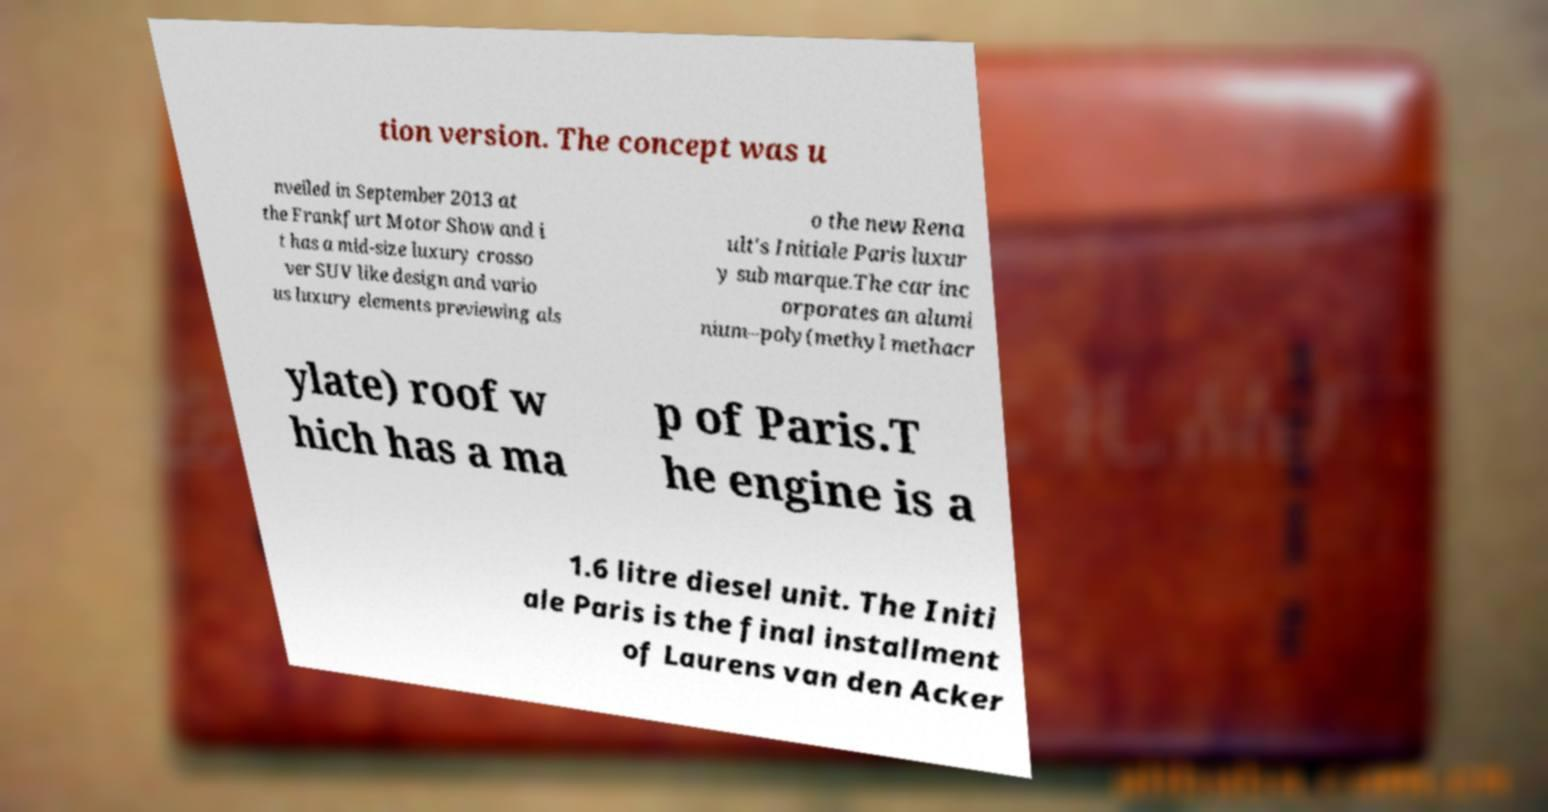I need the written content from this picture converted into text. Can you do that? tion version. The concept was u nveiled in September 2013 at the Frankfurt Motor Show and i t has a mid-size luxury crosso ver SUV like design and vario us luxury elements previewing als o the new Rena ult's Initiale Paris luxur y sub marque.The car inc orporates an alumi nium–poly(methyl methacr ylate) roof w hich has a ma p of Paris.T he engine is a 1.6 litre diesel unit. The Initi ale Paris is the final installment of Laurens van den Acker 